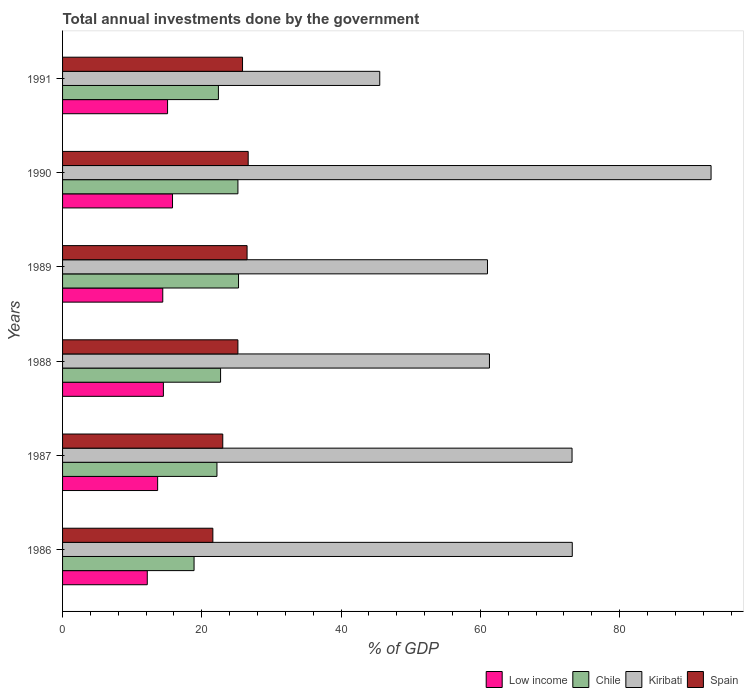How many different coloured bars are there?
Offer a very short reply. 4. How many bars are there on the 6th tick from the bottom?
Give a very brief answer. 4. What is the total annual investments done by the government in Spain in 1986?
Keep it short and to the point. 21.58. Across all years, what is the maximum total annual investments done by the government in Spain?
Give a very brief answer. 26.66. Across all years, what is the minimum total annual investments done by the government in Kiribati?
Keep it short and to the point. 45.55. In which year was the total annual investments done by the government in Low income minimum?
Give a very brief answer. 1986. What is the total total annual investments done by the government in Chile in the graph?
Offer a very short reply. 136.58. What is the difference between the total annual investments done by the government in Kiribati in 1987 and that in 1991?
Your response must be concise. 27.62. What is the difference between the total annual investments done by the government in Kiribati in 1987 and the total annual investments done by the government in Chile in 1991?
Give a very brief answer. 50.78. What is the average total annual investments done by the government in Low income per year?
Ensure brevity in your answer.  14.26. In the year 1988, what is the difference between the total annual investments done by the government in Chile and total annual investments done by the government in Kiribati?
Provide a short and direct response. -38.61. In how many years, is the total annual investments done by the government in Kiribati greater than 80 %?
Offer a terse response. 1. What is the ratio of the total annual investments done by the government in Spain in 1986 to that in 1990?
Your response must be concise. 0.81. Is the total annual investments done by the government in Chile in 1986 less than that in 1987?
Offer a terse response. Yes. Is the difference between the total annual investments done by the government in Chile in 1987 and 1991 greater than the difference between the total annual investments done by the government in Kiribati in 1987 and 1991?
Your response must be concise. No. What is the difference between the highest and the second highest total annual investments done by the government in Chile?
Provide a short and direct response. 0.09. What is the difference between the highest and the lowest total annual investments done by the government in Chile?
Keep it short and to the point. 6.38. Is the sum of the total annual investments done by the government in Spain in 1986 and 1991 greater than the maximum total annual investments done by the government in Kiribati across all years?
Ensure brevity in your answer.  No. Is it the case that in every year, the sum of the total annual investments done by the government in Kiribati and total annual investments done by the government in Low income is greater than the sum of total annual investments done by the government in Chile and total annual investments done by the government in Spain?
Give a very brief answer. No. What does the 4th bar from the top in 1990 represents?
Provide a succinct answer. Low income. What does the 2nd bar from the bottom in 1989 represents?
Your response must be concise. Chile. Is it the case that in every year, the sum of the total annual investments done by the government in Chile and total annual investments done by the government in Spain is greater than the total annual investments done by the government in Kiribati?
Ensure brevity in your answer.  No. How many bars are there?
Provide a succinct answer. 24. How many years are there in the graph?
Make the answer very short. 6. What is the difference between two consecutive major ticks on the X-axis?
Offer a terse response. 20. Are the values on the major ticks of X-axis written in scientific E-notation?
Keep it short and to the point. No. Where does the legend appear in the graph?
Provide a short and direct response. Bottom right. How many legend labels are there?
Your answer should be compact. 4. How are the legend labels stacked?
Offer a very short reply. Horizontal. What is the title of the graph?
Give a very brief answer. Total annual investments done by the government. Does "Germany" appear as one of the legend labels in the graph?
Make the answer very short. No. What is the label or title of the X-axis?
Ensure brevity in your answer.  % of GDP. What is the label or title of the Y-axis?
Make the answer very short. Years. What is the % of GDP in Low income in 1986?
Offer a very short reply. 12.17. What is the % of GDP of Chile in 1986?
Provide a short and direct response. 18.88. What is the % of GDP of Kiribati in 1986?
Offer a very short reply. 73.2. What is the % of GDP in Spain in 1986?
Keep it short and to the point. 21.58. What is the % of GDP of Low income in 1987?
Ensure brevity in your answer.  13.65. What is the % of GDP of Chile in 1987?
Keep it short and to the point. 22.17. What is the % of GDP in Kiribati in 1987?
Your response must be concise. 73.17. What is the % of GDP in Spain in 1987?
Make the answer very short. 23.01. What is the % of GDP of Low income in 1988?
Provide a short and direct response. 14.48. What is the % of GDP in Chile in 1988?
Ensure brevity in your answer.  22.69. What is the % of GDP of Kiribati in 1988?
Offer a terse response. 61.3. What is the % of GDP in Spain in 1988?
Provide a succinct answer. 25.18. What is the % of GDP of Low income in 1989?
Make the answer very short. 14.39. What is the % of GDP in Chile in 1989?
Ensure brevity in your answer.  25.27. What is the % of GDP of Kiribati in 1989?
Offer a terse response. 61.02. What is the % of GDP in Spain in 1989?
Give a very brief answer. 26.5. What is the % of GDP of Low income in 1990?
Offer a very short reply. 15.79. What is the % of GDP of Chile in 1990?
Offer a very short reply. 25.18. What is the % of GDP of Kiribati in 1990?
Ensure brevity in your answer.  93.13. What is the % of GDP in Spain in 1990?
Offer a terse response. 26.66. What is the % of GDP of Low income in 1991?
Your response must be concise. 15.08. What is the % of GDP in Chile in 1991?
Ensure brevity in your answer.  22.38. What is the % of GDP in Kiribati in 1991?
Keep it short and to the point. 45.55. What is the % of GDP in Spain in 1991?
Make the answer very short. 25.84. Across all years, what is the maximum % of GDP in Low income?
Your response must be concise. 15.79. Across all years, what is the maximum % of GDP in Chile?
Offer a terse response. 25.27. Across all years, what is the maximum % of GDP in Kiribati?
Offer a very short reply. 93.13. Across all years, what is the maximum % of GDP in Spain?
Keep it short and to the point. 26.66. Across all years, what is the minimum % of GDP of Low income?
Your answer should be very brief. 12.17. Across all years, what is the minimum % of GDP of Chile?
Offer a very short reply. 18.88. Across all years, what is the minimum % of GDP of Kiribati?
Give a very brief answer. 45.55. Across all years, what is the minimum % of GDP of Spain?
Your response must be concise. 21.58. What is the total % of GDP in Low income in the graph?
Ensure brevity in your answer.  85.55. What is the total % of GDP in Chile in the graph?
Make the answer very short. 136.58. What is the total % of GDP of Kiribati in the graph?
Make the answer very short. 407.37. What is the total % of GDP of Spain in the graph?
Give a very brief answer. 148.77. What is the difference between the % of GDP of Low income in 1986 and that in 1987?
Give a very brief answer. -1.49. What is the difference between the % of GDP in Chile in 1986 and that in 1987?
Ensure brevity in your answer.  -3.29. What is the difference between the % of GDP of Kiribati in 1986 and that in 1987?
Your answer should be compact. 0.03. What is the difference between the % of GDP of Spain in 1986 and that in 1987?
Keep it short and to the point. -1.42. What is the difference between the % of GDP of Low income in 1986 and that in 1988?
Give a very brief answer. -2.31. What is the difference between the % of GDP of Chile in 1986 and that in 1988?
Your answer should be compact. -3.81. What is the difference between the % of GDP in Kiribati in 1986 and that in 1988?
Provide a succinct answer. 11.89. What is the difference between the % of GDP of Spain in 1986 and that in 1988?
Provide a short and direct response. -3.6. What is the difference between the % of GDP of Low income in 1986 and that in 1989?
Make the answer very short. -2.22. What is the difference between the % of GDP of Chile in 1986 and that in 1989?
Give a very brief answer. -6.38. What is the difference between the % of GDP of Kiribati in 1986 and that in 1989?
Provide a short and direct response. 12.18. What is the difference between the % of GDP in Spain in 1986 and that in 1989?
Provide a short and direct response. -4.91. What is the difference between the % of GDP in Low income in 1986 and that in 1990?
Your answer should be very brief. -3.62. What is the difference between the % of GDP of Chile in 1986 and that in 1990?
Your response must be concise. -6.3. What is the difference between the % of GDP in Kiribati in 1986 and that in 1990?
Your response must be concise. -19.93. What is the difference between the % of GDP in Spain in 1986 and that in 1990?
Make the answer very short. -5.07. What is the difference between the % of GDP of Low income in 1986 and that in 1991?
Offer a terse response. -2.91. What is the difference between the % of GDP of Chile in 1986 and that in 1991?
Make the answer very short. -3.5. What is the difference between the % of GDP of Kiribati in 1986 and that in 1991?
Offer a very short reply. 27.65. What is the difference between the % of GDP in Spain in 1986 and that in 1991?
Offer a very short reply. -4.26. What is the difference between the % of GDP of Low income in 1987 and that in 1988?
Ensure brevity in your answer.  -0.83. What is the difference between the % of GDP in Chile in 1987 and that in 1988?
Offer a very short reply. -0.52. What is the difference between the % of GDP in Kiribati in 1987 and that in 1988?
Your answer should be very brief. 11.86. What is the difference between the % of GDP in Spain in 1987 and that in 1988?
Offer a terse response. -2.17. What is the difference between the % of GDP of Low income in 1987 and that in 1989?
Provide a short and direct response. -0.74. What is the difference between the % of GDP of Chile in 1987 and that in 1989?
Make the answer very short. -3.1. What is the difference between the % of GDP of Kiribati in 1987 and that in 1989?
Offer a terse response. 12.14. What is the difference between the % of GDP of Spain in 1987 and that in 1989?
Your answer should be compact. -3.49. What is the difference between the % of GDP of Low income in 1987 and that in 1990?
Your response must be concise. -2.14. What is the difference between the % of GDP in Chile in 1987 and that in 1990?
Keep it short and to the point. -3.01. What is the difference between the % of GDP of Kiribati in 1987 and that in 1990?
Offer a terse response. -19.96. What is the difference between the % of GDP in Spain in 1987 and that in 1990?
Make the answer very short. -3.65. What is the difference between the % of GDP of Low income in 1987 and that in 1991?
Your response must be concise. -1.42. What is the difference between the % of GDP in Chile in 1987 and that in 1991?
Ensure brevity in your answer.  -0.21. What is the difference between the % of GDP of Kiribati in 1987 and that in 1991?
Offer a terse response. 27.62. What is the difference between the % of GDP of Spain in 1987 and that in 1991?
Offer a very short reply. -2.84. What is the difference between the % of GDP in Low income in 1988 and that in 1989?
Your answer should be very brief. 0.09. What is the difference between the % of GDP of Chile in 1988 and that in 1989?
Offer a very short reply. -2.58. What is the difference between the % of GDP in Kiribati in 1988 and that in 1989?
Ensure brevity in your answer.  0.28. What is the difference between the % of GDP of Spain in 1988 and that in 1989?
Your answer should be compact. -1.32. What is the difference between the % of GDP in Low income in 1988 and that in 1990?
Keep it short and to the point. -1.31. What is the difference between the % of GDP of Chile in 1988 and that in 1990?
Offer a terse response. -2.49. What is the difference between the % of GDP in Kiribati in 1988 and that in 1990?
Keep it short and to the point. -31.82. What is the difference between the % of GDP of Spain in 1988 and that in 1990?
Ensure brevity in your answer.  -1.48. What is the difference between the % of GDP of Low income in 1988 and that in 1991?
Provide a succinct answer. -0.6. What is the difference between the % of GDP in Chile in 1988 and that in 1991?
Your answer should be compact. 0.31. What is the difference between the % of GDP in Kiribati in 1988 and that in 1991?
Provide a short and direct response. 15.76. What is the difference between the % of GDP in Spain in 1988 and that in 1991?
Offer a terse response. -0.66. What is the difference between the % of GDP in Low income in 1989 and that in 1990?
Your answer should be compact. -1.4. What is the difference between the % of GDP in Chile in 1989 and that in 1990?
Make the answer very short. 0.09. What is the difference between the % of GDP in Kiribati in 1989 and that in 1990?
Offer a very short reply. -32.11. What is the difference between the % of GDP of Spain in 1989 and that in 1990?
Provide a succinct answer. -0.16. What is the difference between the % of GDP in Low income in 1989 and that in 1991?
Offer a very short reply. -0.69. What is the difference between the % of GDP in Chile in 1989 and that in 1991?
Offer a terse response. 2.89. What is the difference between the % of GDP in Kiribati in 1989 and that in 1991?
Your answer should be very brief. 15.47. What is the difference between the % of GDP in Spain in 1989 and that in 1991?
Offer a terse response. 0.65. What is the difference between the % of GDP in Low income in 1990 and that in 1991?
Your response must be concise. 0.71. What is the difference between the % of GDP in Chile in 1990 and that in 1991?
Provide a succinct answer. 2.8. What is the difference between the % of GDP of Kiribati in 1990 and that in 1991?
Offer a very short reply. 47.58. What is the difference between the % of GDP of Spain in 1990 and that in 1991?
Keep it short and to the point. 0.81. What is the difference between the % of GDP of Low income in 1986 and the % of GDP of Chile in 1987?
Keep it short and to the point. -10. What is the difference between the % of GDP in Low income in 1986 and the % of GDP in Kiribati in 1987?
Keep it short and to the point. -61. What is the difference between the % of GDP in Low income in 1986 and the % of GDP in Spain in 1987?
Ensure brevity in your answer.  -10.84. What is the difference between the % of GDP of Chile in 1986 and the % of GDP of Kiribati in 1987?
Provide a succinct answer. -54.28. What is the difference between the % of GDP of Chile in 1986 and the % of GDP of Spain in 1987?
Give a very brief answer. -4.12. What is the difference between the % of GDP of Kiribati in 1986 and the % of GDP of Spain in 1987?
Ensure brevity in your answer.  50.19. What is the difference between the % of GDP in Low income in 1986 and the % of GDP in Chile in 1988?
Offer a very short reply. -10.53. What is the difference between the % of GDP in Low income in 1986 and the % of GDP in Kiribati in 1988?
Offer a terse response. -49.14. What is the difference between the % of GDP of Low income in 1986 and the % of GDP of Spain in 1988?
Your answer should be very brief. -13.01. What is the difference between the % of GDP of Chile in 1986 and the % of GDP of Kiribati in 1988?
Provide a short and direct response. -42.42. What is the difference between the % of GDP of Chile in 1986 and the % of GDP of Spain in 1988?
Your response must be concise. -6.3. What is the difference between the % of GDP in Kiribati in 1986 and the % of GDP in Spain in 1988?
Your answer should be very brief. 48.02. What is the difference between the % of GDP of Low income in 1986 and the % of GDP of Chile in 1989?
Ensure brevity in your answer.  -13.1. What is the difference between the % of GDP of Low income in 1986 and the % of GDP of Kiribati in 1989?
Your answer should be very brief. -48.86. What is the difference between the % of GDP of Low income in 1986 and the % of GDP of Spain in 1989?
Provide a succinct answer. -14.33. What is the difference between the % of GDP in Chile in 1986 and the % of GDP in Kiribati in 1989?
Provide a short and direct response. -42.14. What is the difference between the % of GDP in Chile in 1986 and the % of GDP in Spain in 1989?
Offer a terse response. -7.61. What is the difference between the % of GDP of Kiribati in 1986 and the % of GDP of Spain in 1989?
Ensure brevity in your answer.  46.7. What is the difference between the % of GDP in Low income in 1986 and the % of GDP in Chile in 1990?
Give a very brief answer. -13.02. What is the difference between the % of GDP in Low income in 1986 and the % of GDP in Kiribati in 1990?
Offer a very short reply. -80.96. What is the difference between the % of GDP of Low income in 1986 and the % of GDP of Spain in 1990?
Provide a succinct answer. -14.49. What is the difference between the % of GDP of Chile in 1986 and the % of GDP of Kiribati in 1990?
Provide a short and direct response. -74.24. What is the difference between the % of GDP in Chile in 1986 and the % of GDP in Spain in 1990?
Your answer should be compact. -7.77. What is the difference between the % of GDP of Kiribati in 1986 and the % of GDP of Spain in 1990?
Offer a very short reply. 46.54. What is the difference between the % of GDP of Low income in 1986 and the % of GDP of Chile in 1991?
Keep it short and to the point. -10.22. What is the difference between the % of GDP in Low income in 1986 and the % of GDP in Kiribati in 1991?
Keep it short and to the point. -33.38. What is the difference between the % of GDP in Low income in 1986 and the % of GDP in Spain in 1991?
Ensure brevity in your answer.  -13.68. What is the difference between the % of GDP in Chile in 1986 and the % of GDP in Kiribati in 1991?
Ensure brevity in your answer.  -26.66. What is the difference between the % of GDP of Chile in 1986 and the % of GDP of Spain in 1991?
Keep it short and to the point. -6.96. What is the difference between the % of GDP of Kiribati in 1986 and the % of GDP of Spain in 1991?
Keep it short and to the point. 47.35. What is the difference between the % of GDP in Low income in 1987 and the % of GDP in Chile in 1988?
Your response must be concise. -9.04. What is the difference between the % of GDP in Low income in 1987 and the % of GDP in Kiribati in 1988?
Give a very brief answer. -47.65. What is the difference between the % of GDP in Low income in 1987 and the % of GDP in Spain in 1988?
Your answer should be compact. -11.53. What is the difference between the % of GDP of Chile in 1987 and the % of GDP of Kiribati in 1988?
Give a very brief answer. -39.13. What is the difference between the % of GDP of Chile in 1987 and the % of GDP of Spain in 1988?
Offer a very short reply. -3.01. What is the difference between the % of GDP of Kiribati in 1987 and the % of GDP of Spain in 1988?
Ensure brevity in your answer.  47.99. What is the difference between the % of GDP in Low income in 1987 and the % of GDP in Chile in 1989?
Make the answer very short. -11.62. What is the difference between the % of GDP in Low income in 1987 and the % of GDP in Kiribati in 1989?
Keep it short and to the point. -47.37. What is the difference between the % of GDP in Low income in 1987 and the % of GDP in Spain in 1989?
Your response must be concise. -12.85. What is the difference between the % of GDP of Chile in 1987 and the % of GDP of Kiribati in 1989?
Give a very brief answer. -38.85. What is the difference between the % of GDP of Chile in 1987 and the % of GDP of Spain in 1989?
Provide a short and direct response. -4.33. What is the difference between the % of GDP in Kiribati in 1987 and the % of GDP in Spain in 1989?
Ensure brevity in your answer.  46.67. What is the difference between the % of GDP in Low income in 1987 and the % of GDP in Chile in 1990?
Give a very brief answer. -11.53. What is the difference between the % of GDP of Low income in 1987 and the % of GDP of Kiribati in 1990?
Provide a succinct answer. -79.48. What is the difference between the % of GDP of Low income in 1987 and the % of GDP of Spain in 1990?
Offer a very short reply. -13.01. What is the difference between the % of GDP of Chile in 1987 and the % of GDP of Kiribati in 1990?
Your answer should be very brief. -70.96. What is the difference between the % of GDP of Chile in 1987 and the % of GDP of Spain in 1990?
Offer a very short reply. -4.49. What is the difference between the % of GDP of Kiribati in 1987 and the % of GDP of Spain in 1990?
Ensure brevity in your answer.  46.51. What is the difference between the % of GDP of Low income in 1987 and the % of GDP of Chile in 1991?
Provide a short and direct response. -8.73. What is the difference between the % of GDP of Low income in 1987 and the % of GDP of Kiribati in 1991?
Your answer should be very brief. -31.9. What is the difference between the % of GDP in Low income in 1987 and the % of GDP in Spain in 1991?
Your answer should be very brief. -12.19. What is the difference between the % of GDP of Chile in 1987 and the % of GDP of Kiribati in 1991?
Make the answer very short. -23.38. What is the difference between the % of GDP in Chile in 1987 and the % of GDP in Spain in 1991?
Keep it short and to the point. -3.67. What is the difference between the % of GDP of Kiribati in 1987 and the % of GDP of Spain in 1991?
Your answer should be very brief. 47.32. What is the difference between the % of GDP of Low income in 1988 and the % of GDP of Chile in 1989?
Give a very brief answer. -10.79. What is the difference between the % of GDP in Low income in 1988 and the % of GDP in Kiribati in 1989?
Ensure brevity in your answer.  -46.54. What is the difference between the % of GDP of Low income in 1988 and the % of GDP of Spain in 1989?
Provide a short and direct response. -12.02. What is the difference between the % of GDP of Chile in 1988 and the % of GDP of Kiribati in 1989?
Provide a short and direct response. -38.33. What is the difference between the % of GDP in Chile in 1988 and the % of GDP in Spain in 1989?
Ensure brevity in your answer.  -3.81. What is the difference between the % of GDP of Kiribati in 1988 and the % of GDP of Spain in 1989?
Offer a very short reply. 34.81. What is the difference between the % of GDP of Low income in 1988 and the % of GDP of Chile in 1990?
Keep it short and to the point. -10.7. What is the difference between the % of GDP of Low income in 1988 and the % of GDP of Kiribati in 1990?
Keep it short and to the point. -78.65. What is the difference between the % of GDP of Low income in 1988 and the % of GDP of Spain in 1990?
Offer a very short reply. -12.18. What is the difference between the % of GDP in Chile in 1988 and the % of GDP in Kiribati in 1990?
Offer a terse response. -70.44. What is the difference between the % of GDP in Chile in 1988 and the % of GDP in Spain in 1990?
Provide a succinct answer. -3.97. What is the difference between the % of GDP in Kiribati in 1988 and the % of GDP in Spain in 1990?
Make the answer very short. 34.65. What is the difference between the % of GDP of Low income in 1988 and the % of GDP of Chile in 1991?
Offer a terse response. -7.9. What is the difference between the % of GDP of Low income in 1988 and the % of GDP of Kiribati in 1991?
Make the answer very short. -31.07. What is the difference between the % of GDP in Low income in 1988 and the % of GDP in Spain in 1991?
Provide a succinct answer. -11.36. What is the difference between the % of GDP of Chile in 1988 and the % of GDP of Kiribati in 1991?
Your answer should be compact. -22.86. What is the difference between the % of GDP of Chile in 1988 and the % of GDP of Spain in 1991?
Offer a terse response. -3.15. What is the difference between the % of GDP of Kiribati in 1988 and the % of GDP of Spain in 1991?
Make the answer very short. 35.46. What is the difference between the % of GDP in Low income in 1989 and the % of GDP in Chile in 1990?
Ensure brevity in your answer.  -10.79. What is the difference between the % of GDP in Low income in 1989 and the % of GDP in Kiribati in 1990?
Keep it short and to the point. -78.74. What is the difference between the % of GDP of Low income in 1989 and the % of GDP of Spain in 1990?
Offer a terse response. -12.27. What is the difference between the % of GDP of Chile in 1989 and the % of GDP of Kiribati in 1990?
Provide a short and direct response. -67.86. What is the difference between the % of GDP in Chile in 1989 and the % of GDP in Spain in 1990?
Your answer should be compact. -1.39. What is the difference between the % of GDP of Kiribati in 1989 and the % of GDP of Spain in 1990?
Your response must be concise. 34.36. What is the difference between the % of GDP of Low income in 1989 and the % of GDP of Chile in 1991?
Your answer should be very brief. -7.99. What is the difference between the % of GDP in Low income in 1989 and the % of GDP in Kiribati in 1991?
Ensure brevity in your answer.  -31.16. What is the difference between the % of GDP of Low income in 1989 and the % of GDP of Spain in 1991?
Make the answer very short. -11.46. What is the difference between the % of GDP of Chile in 1989 and the % of GDP of Kiribati in 1991?
Give a very brief answer. -20.28. What is the difference between the % of GDP of Chile in 1989 and the % of GDP of Spain in 1991?
Offer a terse response. -0.57. What is the difference between the % of GDP in Kiribati in 1989 and the % of GDP in Spain in 1991?
Your answer should be compact. 35.18. What is the difference between the % of GDP of Low income in 1990 and the % of GDP of Chile in 1991?
Make the answer very short. -6.59. What is the difference between the % of GDP in Low income in 1990 and the % of GDP in Kiribati in 1991?
Your response must be concise. -29.76. What is the difference between the % of GDP of Low income in 1990 and the % of GDP of Spain in 1991?
Ensure brevity in your answer.  -10.05. What is the difference between the % of GDP in Chile in 1990 and the % of GDP in Kiribati in 1991?
Your answer should be very brief. -20.37. What is the difference between the % of GDP of Chile in 1990 and the % of GDP of Spain in 1991?
Make the answer very short. -0.66. What is the difference between the % of GDP in Kiribati in 1990 and the % of GDP in Spain in 1991?
Provide a short and direct response. 67.29. What is the average % of GDP in Low income per year?
Keep it short and to the point. 14.26. What is the average % of GDP of Chile per year?
Ensure brevity in your answer.  22.76. What is the average % of GDP in Kiribati per year?
Offer a very short reply. 67.89. What is the average % of GDP of Spain per year?
Offer a terse response. 24.79. In the year 1986, what is the difference between the % of GDP of Low income and % of GDP of Chile?
Your answer should be very brief. -6.72. In the year 1986, what is the difference between the % of GDP in Low income and % of GDP in Kiribati?
Make the answer very short. -61.03. In the year 1986, what is the difference between the % of GDP in Low income and % of GDP in Spain?
Offer a very short reply. -9.42. In the year 1986, what is the difference between the % of GDP of Chile and % of GDP of Kiribati?
Provide a succinct answer. -54.31. In the year 1986, what is the difference between the % of GDP of Chile and % of GDP of Spain?
Your answer should be very brief. -2.7. In the year 1986, what is the difference between the % of GDP of Kiribati and % of GDP of Spain?
Your response must be concise. 51.61. In the year 1987, what is the difference between the % of GDP of Low income and % of GDP of Chile?
Keep it short and to the point. -8.52. In the year 1987, what is the difference between the % of GDP in Low income and % of GDP in Kiribati?
Your answer should be compact. -59.51. In the year 1987, what is the difference between the % of GDP in Low income and % of GDP in Spain?
Give a very brief answer. -9.35. In the year 1987, what is the difference between the % of GDP in Chile and % of GDP in Kiribati?
Your response must be concise. -51. In the year 1987, what is the difference between the % of GDP in Chile and % of GDP in Spain?
Your answer should be compact. -0.84. In the year 1987, what is the difference between the % of GDP of Kiribati and % of GDP of Spain?
Your answer should be compact. 50.16. In the year 1988, what is the difference between the % of GDP of Low income and % of GDP of Chile?
Your answer should be compact. -8.21. In the year 1988, what is the difference between the % of GDP of Low income and % of GDP of Kiribati?
Your answer should be compact. -46.83. In the year 1988, what is the difference between the % of GDP in Low income and % of GDP in Spain?
Ensure brevity in your answer.  -10.7. In the year 1988, what is the difference between the % of GDP in Chile and % of GDP in Kiribati?
Provide a short and direct response. -38.61. In the year 1988, what is the difference between the % of GDP in Chile and % of GDP in Spain?
Your response must be concise. -2.49. In the year 1988, what is the difference between the % of GDP of Kiribati and % of GDP of Spain?
Provide a succinct answer. 36.12. In the year 1989, what is the difference between the % of GDP in Low income and % of GDP in Chile?
Offer a terse response. -10.88. In the year 1989, what is the difference between the % of GDP of Low income and % of GDP of Kiribati?
Provide a short and direct response. -46.63. In the year 1989, what is the difference between the % of GDP of Low income and % of GDP of Spain?
Give a very brief answer. -12.11. In the year 1989, what is the difference between the % of GDP of Chile and % of GDP of Kiribati?
Give a very brief answer. -35.75. In the year 1989, what is the difference between the % of GDP of Chile and % of GDP of Spain?
Give a very brief answer. -1.23. In the year 1989, what is the difference between the % of GDP of Kiribati and % of GDP of Spain?
Ensure brevity in your answer.  34.52. In the year 1990, what is the difference between the % of GDP of Low income and % of GDP of Chile?
Give a very brief answer. -9.39. In the year 1990, what is the difference between the % of GDP of Low income and % of GDP of Kiribati?
Ensure brevity in your answer.  -77.34. In the year 1990, what is the difference between the % of GDP in Low income and % of GDP in Spain?
Offer a very short reply. -10.87. In the year 1990, what is the difference between the % of GDP in Chile and % of GDP in Kiribati?
Provide a succinct answer. -67.95. In the year 1990, what is the difference between the % of GDP of Chile and % of GDP of Spain?
Ensure brevity in your answer.  -1.47. In the year 1990, what is the difference between the % of GDP in Kiribati and % of GDP in Spain?
Your answer should be very brief. 66.47. In the year 1991, what is the difference between the % of GDP of Low income and % of GDP of Chile?
Ensure brevity in your answer.  -7.3. In the year 1991, what is the difference between the % of GDP in Low income and % of GDP in Kiribati?
Your answer should be compact. -30.47. In the year 1991, what is the difference between the % of GDP in Low income and % of GDP in Spain?
Your answer should be very brief. -10.77. In the year 1991, what is the difference between the % of GDP in Chile and % of GDP in Kiribati?
Offer a very short reply. -23.17. In the year 1991, what is the difference between the % of GDP in Chile and % of GDP in Spain?
Provide a succinct answer. -3.46. In the year 1991, what is the difference between the % of GDP in Kiribati and % of GDP in Spain?
Provide a short and direct response. 19.71. What is the ratio of the % of GDP in Low income in 1986 to that in 1987?
Provide a succinct answer. 0.89. What is the ratio of the % of GDP in Chile in 1986 to that in 1987?
Give a very brief answer. 0.85. What is the ratio of the % of GDP in Spain in 1986 to that in 1987?
Provide a succinct answer. 0.94. What is the ratio of the % of GDP in Low income in 1986 to that in 1988?
Offer a terse response. 0.84. What is the ratio of the % of GDP of Chile in 1986 to that in 1988?
Give a very brief answer. 0.83. What is the ratio of the % of GDP in Kiribati in 1986 to that in 1988?
Provide a short and direct response. 1.19. What is the ratio of the % of GDP in Spain in 1986 to that in 1988?
Make the answer very short. 0.86. What is the ratio of the % of GDP in Low income in 1986 to that in 1989?
Provide a succinct answer. 0.85. What is the ratio of the % of GDP of Chile in 1986 to that in 1989?
Your answer should be compact. 0.75. What is the ratio of the % of GDP in Kiribati in 1986 to that in 1989?
Make the answer very short. 1.2. What is the ratio of the % of GDP in Spain in 1986 to that in 1989?
Your response must be concise. 0.81. What is the ratio of the % of GDP of Low income in 1986 to that in 1990?
Ensure brevity in your answer.  0.77. What is the ratio of the % of GDP of Chile in 1986 to that in 1990?
Ensure brevity in your answer.  0.75. What is the ratio of the % of GDP in Kiribati in 1986 to that in 1990?
Your answer should be compact. 0.79. What is the ratio of the % of GDP in Spain in 1986 to that in 1990?
Offer a terse response. 0.81. What is the ratio of the % of GDP of Low income in 1986 to that in 1991?
Your response must be concise. 0.81. What is the ratio of the % of GDP in Chile in 1986 to that in 1991?
Ensure brevity in your answer.  0.84. What is the ratio of the % of GDP in Kiribati in 1986 to that in 1991?
Ensure brevity in your answer.  1.61. What is the ratio of the % of GDP of Spain in 1986 to that in 1991?
Make the answer very short. 0.84. What is the ratio of the % of GDP in Low income in 1987 to that in 1988?
Ensure brevity in your answer.  0.94. What is the ratio of the % of GDP in Chile in 1987 to that in 1988?
Your response must be concise. 0.98. What is the ratio of the % of GDP of Kiribati in 1987 to that in 1988?
Offer a terse response. 1.19. What is the ratio of the % of GDP of Spain in 1987 to that in 1988?
Keep it short and to the point. 0.91. What is the ratio of the % of GDP of Low income in 1987 to that in 1989?
Provide a short and direct response. 0.95. What is the ratio of the % of GDP in Chile in 1987 to that in 1989?
Provide a succinct answer. 0.88. What is the ratio of the % of GDP of Kiribati in 1987 to that in 1989?
Your answer should be very brief. 1.2. What is the ratio of the % of GDP of Spain in 1987 to that in 1989?
Give a very brief answer. 0.87. What is the ratio of the % of GDP in Low income in 1987 to that in 1990?
Your answer should be very brief. 0.86. What is the ratio of the % of GDP of Chile in 1987 to that in 1990?
Your answer should be very brief. 0.88. What is the ratio of the % of GDP of Kiribati in 1987 to that in 1990?
Your answer should be very brief. 0.79. What is the ratio of the % of GDP of Spain in 1987 to that in 1990?
Give a very brief answer. 0.86. What is the ratio of the % of GDP of Low income in 1987 to that in 1991?
Give a very brief answer. 0.91. What is the ratio of the % of GDP in Chile in 1987 to that in 1991?
Give a very brief answer. 0.99. What is the ratio of the % of GDP of Kiribati in 1987 to that in 1991?
Your response must be concise. 1.61. What is the ratio of the % of GDP of Spain in 1987 to that in 1991?
Make the answer very short. 0.89. What is the ratio of the % of GDP of Chile in 1988 to that in 1989?
Ensure brevity in your answer.  0.9. What is the ratio of the % of GDP in Spain in 1988 to that in 1989?
Your answer should be very brief. 0.95. What is the ratio of the % of GDP in Low income in 1988 to that in 1990?
Make the answer very short. 0.92. What is the ratio of the % of GDP of Chile in 1988 to that in 1990?
Your answer should be very brief. 0.9. What is the ratio of the % of GDP in Kiribati in 1988 to that in 1990?
Provide a succinct answer. 0.66. What is the ratio of the % of GDP in Spain in 1988 to that in 1990?
Give a very brief answer. 0.94. What is the ratio of the % of GDP in Low income in 1988 to that in 1991?
Give a very brief answer. 0.96. What is the ratio of the % of GDP of Chile in 1988 to that in 1991?
Provide a short and direct response. 1.01. What is the ratio of the % of GDP in Kiribati in 1988 to that in 1991?
Your response must be concise. 1.35. What is the ratio of the % of GDP of Spain in 1988 to that in 1991?
Your response must be concise. 0.97. What is the ratio of the % of GDP of Low income in 1989 to that in 1990?
Your answer should be compact. 0.91. What is the ratio of the % of GDP in Chile in 1989 to that in 1990?
Provide a succinct answer. 1. What is the ratio of the % of GDP of Kiribati in 1989 to that in 1990?
Make the answer very short. 0.66. What is the ratio of the % of GDP in Low income in 1989 to that in 1991?
Your answer should be compact. 0.95. What is the ratio of the % of GDP in Chile in 1989 to that in 1991?
Give a very brief answer. 1.13. What is the ratio of the % of GDP in Kiribati in 1989 to that in 1991?
Offer a very short reply. 1.34. What is the ratio of the % of GDP of Spain in 1989 to that in 1991?
Provide a short and direct response. 1.03. What is the ratio of the % of GDP of Low income in 1990 to that in 1991?
Make the answer very short. 1.05. What is the ratio of the % of GDP of Chile in 1990 to that in 1991?
Make the answer very short. 1.13. What is the ratio of the % of GDP in Kiribati in 1990 to that in 1991?
Give a very brief answer. 2.04. What is the ratio of the % of GDP in Spain in 1990 to that in 1991?
Offer a very short reply. 1.03. What is the difference between the highest and the second highest % of GDP in Low income?
Make the answer very short. 0.71. What is the difference between the highest and the second highest % of GDP of Chile?
Make the answer very short. 0.09. What is the difference between the highest and the second highest % of GDP of Kiribati?
Your answer should be very brief. 19.93. What is the difference between the highest and the second highest % of GDP in Spain?
Your answer should be compact. 0.16. What is the difference between the highest and the lowest % of GDP of Low income?
Offer a terse response. 3.62. What is the difference between the highest and the lowest % of GDP in Chile?
Offer a very short reply. 6.38. What is the difference between the highest and the lowest % of GDP of Kiribati?
Offer a terse response. 47.58. What is the difference between the highest and the lowest % of GDP in Spain?
Give a very brief answer. 5.07. 